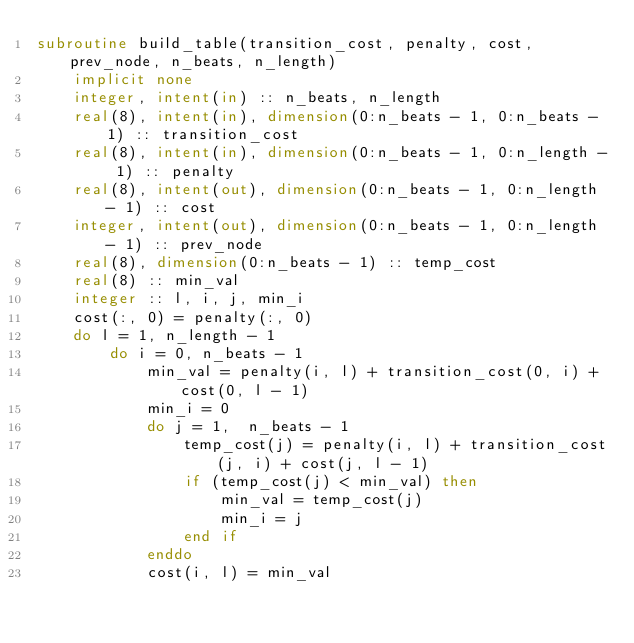Convert code to text. <code><loc_0><loc_0><loc_500><loc_500><_FORTRAN_>subroutine build_table(transition_cost, penalty, cost, prev_node, n_beats, n_length)
    implicit none
    integer, intent(in) :: n_beats, n_length
    real(8), intent(in), dimension(0:n_beats - 1, 0:n_beats - 1) :: transition_cost
    real(8), intent(in), dimension(0:n_beats - 1, 0:n_length - 1) :: penalty
    real(8), intent(out), dimension(0:n_beats - 1, 0:n_length - 1) :: cost
    integer, intent(out), dimension(0:n_beats - 1, 0:n_length - 1) :: prev_node
    real(8), dimension(0:n_beats - 1) :: temp_cost
    real(8) :: min_val
    integer :: l, i, j, min_i
    cost(:, 0) = penalty(:, 0)
    do l = 1, n_length - 1
        do i = 0, n_beats - 1
            min_val = penalty(i, l) + transition_cost(0, i) + cost(0, l - 1)
            min_i = 0
            do j = 1,  n_beats - 1
                temp_cost(j) = penalty(i, l) + transition_cost(j, i) + cost(j, l - 1)
                if (temp_cost(j) < min_val) then
                    min_val = temp_cost(j)
                    min_i = j
                end if
            enddo
            cost(i, l) = min_val</code> 